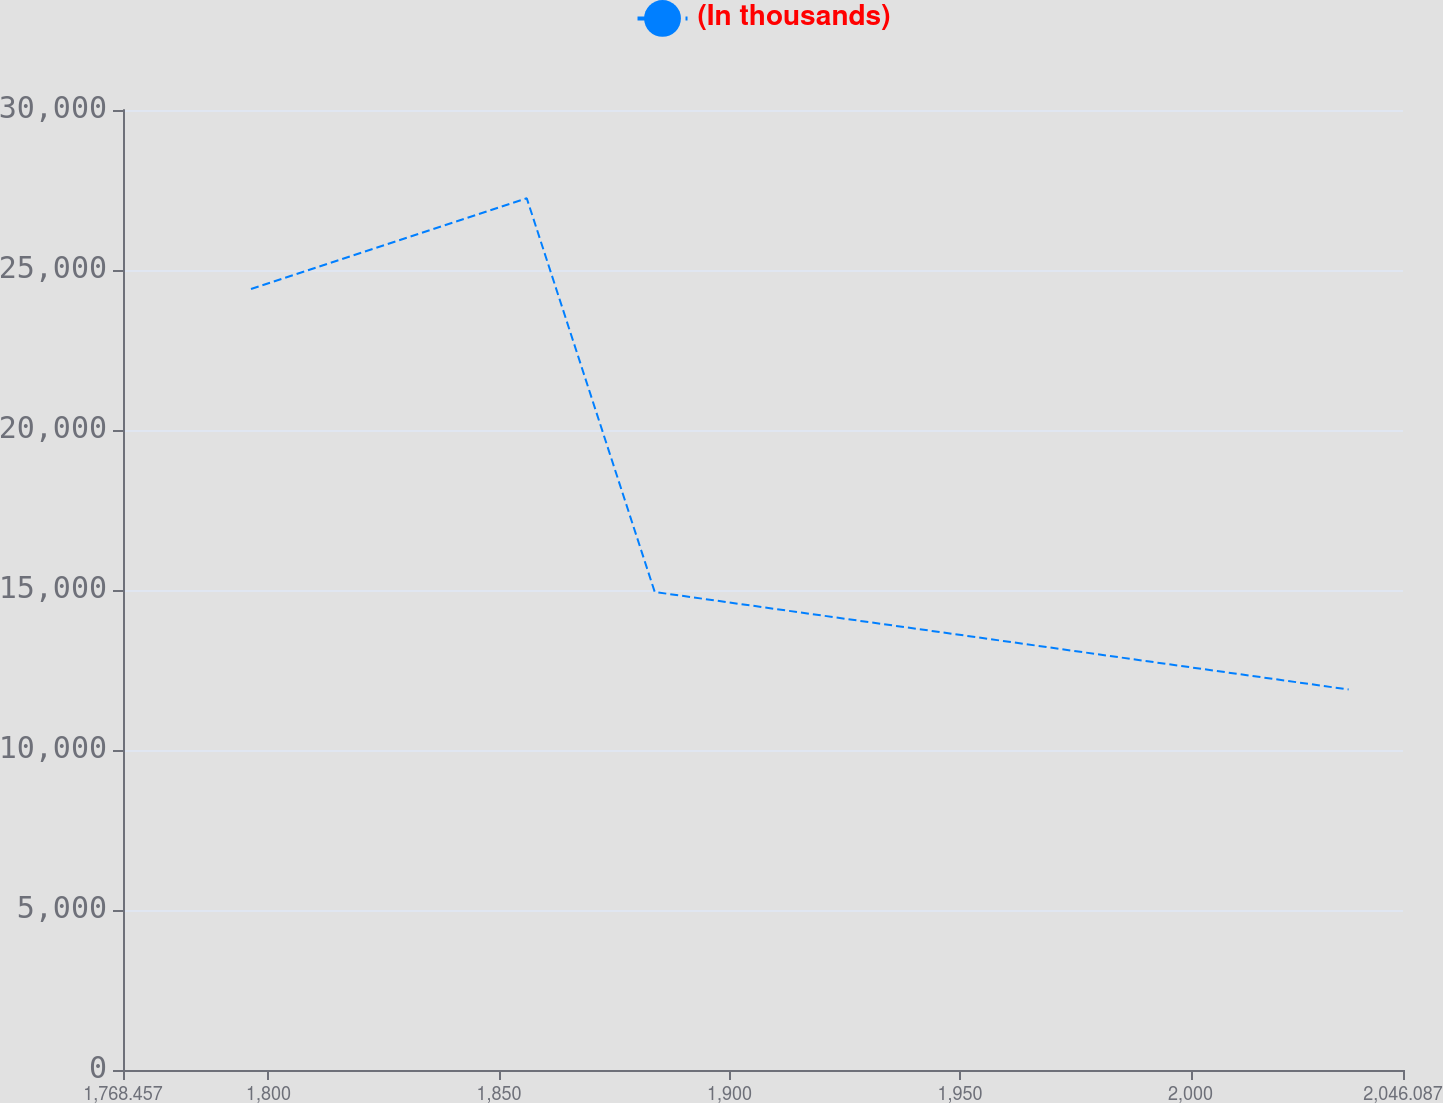<chart> <loc_0><loc_0><loc_500><loc_500><line_chart><ecel><fcel>(In thousands)<nl><fcel>1796.22<fcel>24406.2<nl><fcel>1856.03<fcel>27242.7<nl><fcel>1883.79<fcel>14937.6<nl><fcel>2034.3<fcel>11890.5<nl><fcel>2073.85<fcel>6342.15<nl></chart> 